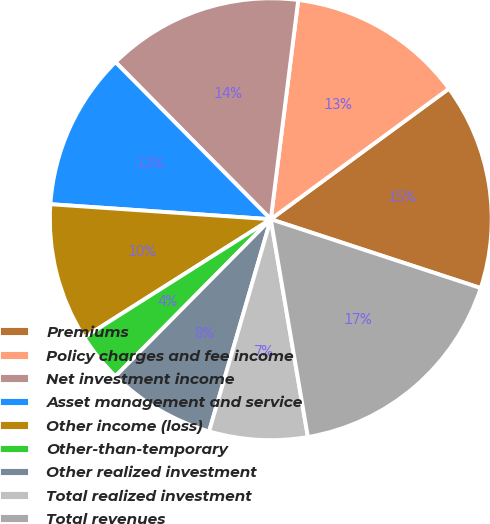Convert chart. <chart><loc_0><loc_0><loc_500><loc_500><pie_chart><fcel>Premiums<fcel>Policy charges and fee income<fcel>Net investment income<fcel>Asset management and service<fcel>Other income (loss)<fcel>Other-than-temporary<fcel>Other realized investment<fcel>Total realized investment<fcel>Total revenues<nl><fcel>15.11%<fcel>12.95%<fcel>14.39%<fcel>11.51%<fcel>10.07%<fcel>3.6%<fcel>7.91%<fcel>7.19%<fcel>17.27%<nl></chart> 